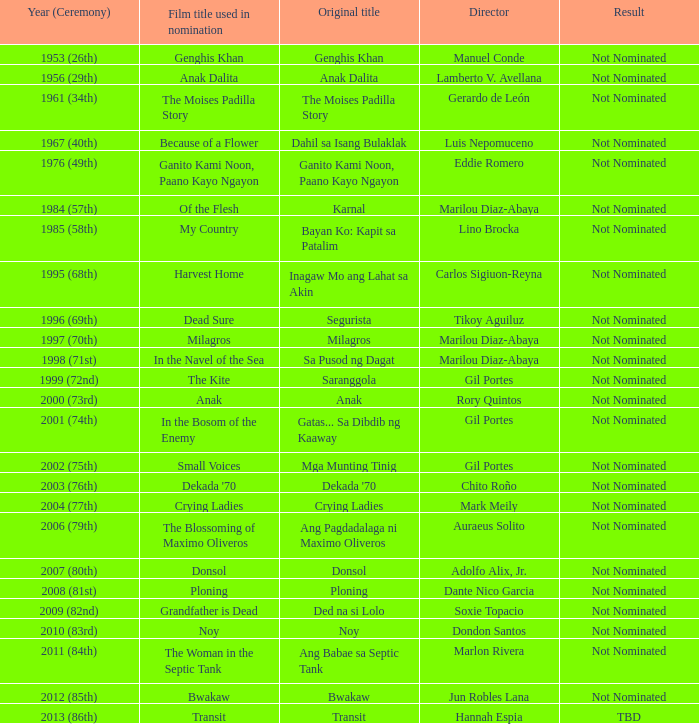Which director had not nominated as a result, and had Bayan Ko: Kapit Sa Patalim as an original title? Lino Brocka. 